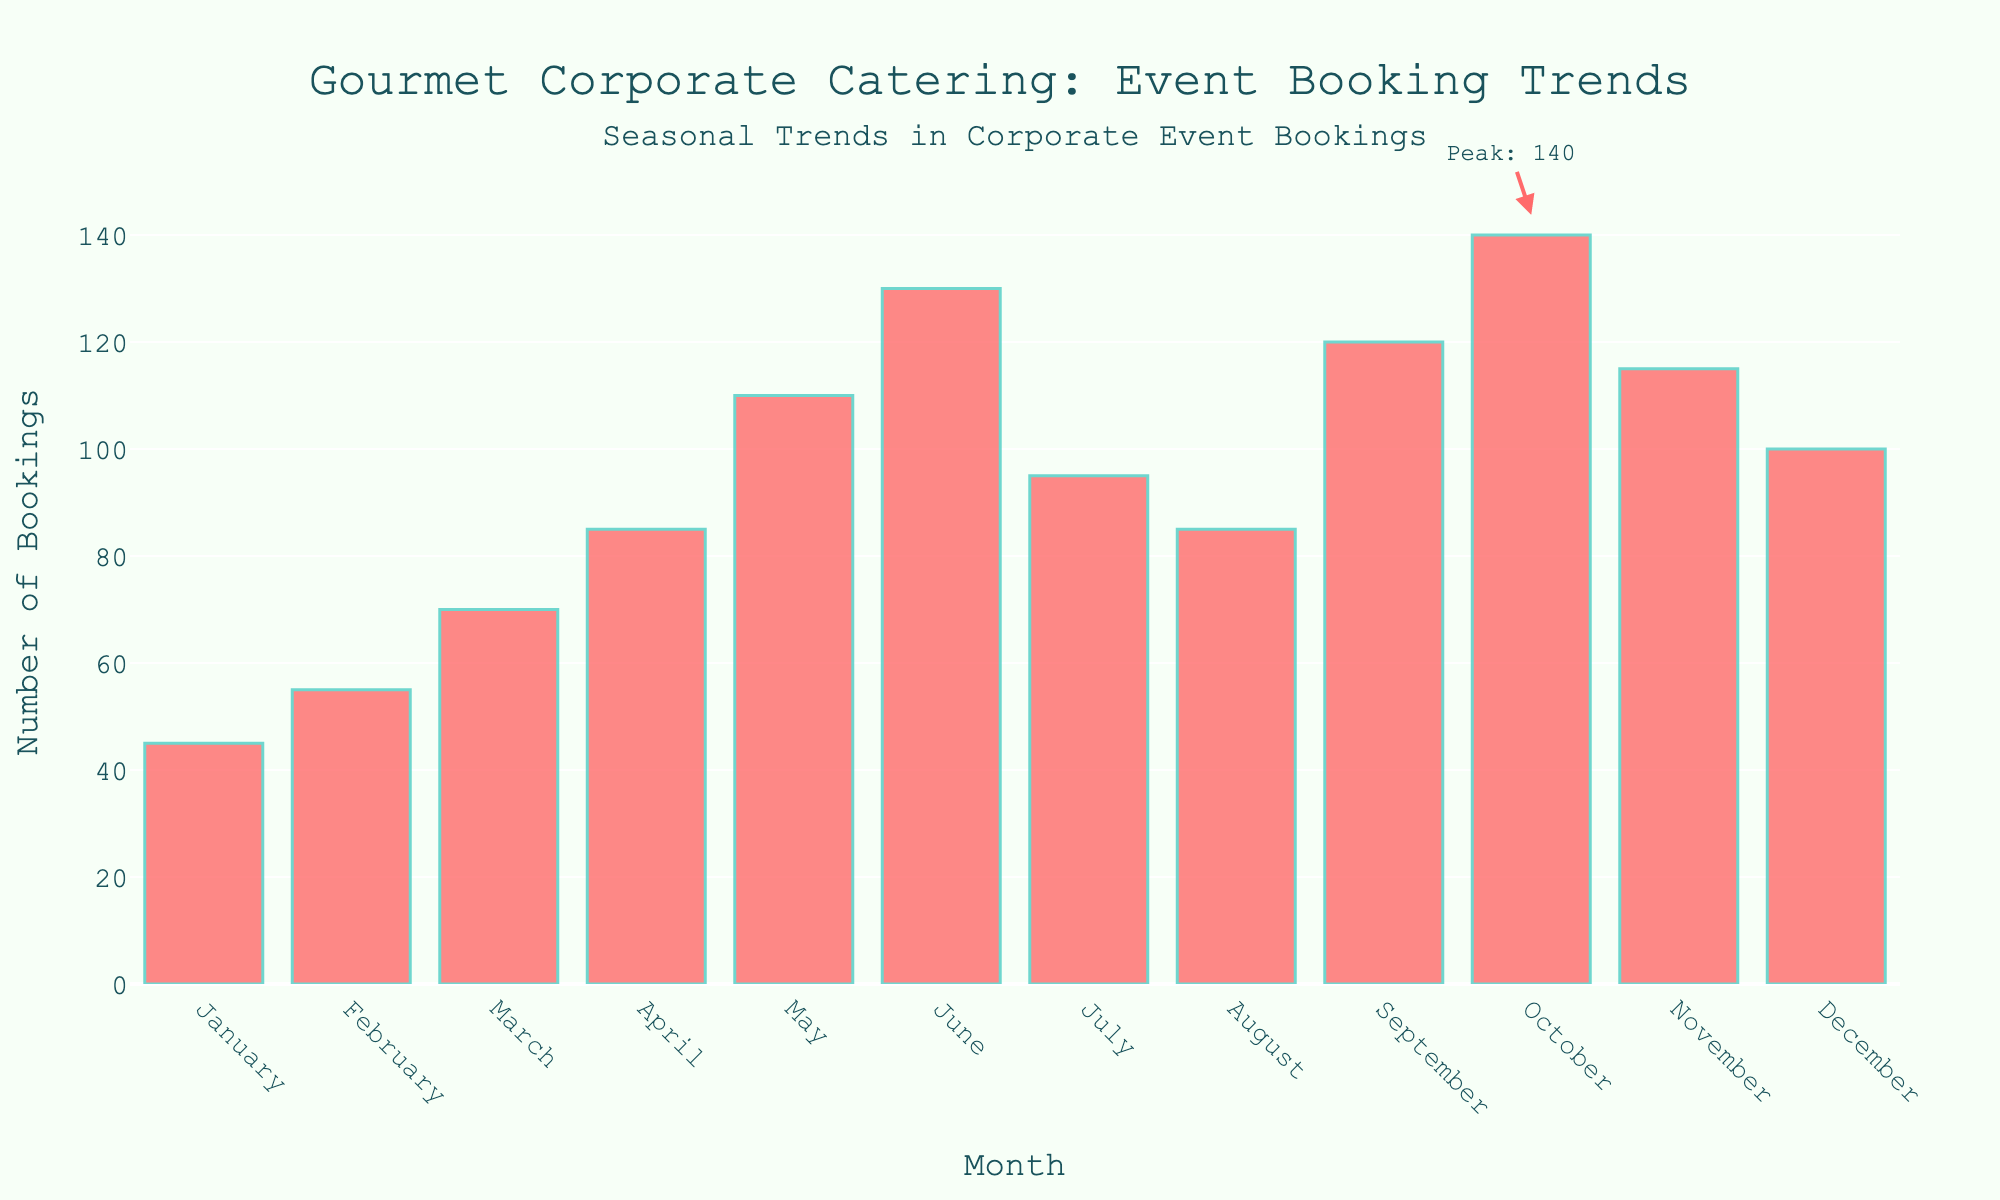What month sees the highest number of bookings? The month with the highest number of bookings can be identified by the tallest bar in the figure. October has the tallest bar.
Answer: October Compare the bookings of July and August. Which month has higher bookings? By looking at the height of the bars for July and August, July's bar is taller than August's.
Answer: July What is the difference in bookings between April and September? The bar for April is at 85 bookings, and the bar for September is at 120 bookings. The difference is 120 - 85 = 35 bookings.
Answer: 35 What is the range of the number of bookings throughout the year? The range can be found by subtracting the shortest bar's value (January with 45 bookings) from the tallest bar's value (October with 140 bookings). The range is 140 - 45 = 95 bookings.
Answer: 95 How many months have bookings above 100? The bars higher than the 100 bookings line are for May, June, September, October, and November. Counting these gives 5 months.
Answer: 5 What is the average number of bookings from January to June? Sum the bookings from January (45), February (55), March (70), April (85), May (110), and June (130). The sum is 495. The average is 495 / 6 = 82.5 bookings.
Answer: 82.5 Do more bookings occur in the first half or the second half of the year? Sum the bookings from January to June: 45 + 55 + 70 + 85 + 110 + 130 = 495. Sum the bookings from July to December: 95 + 85 + 120 + 140 + 115 + 100 = 655. Compare the sums: 655 > 495, so more bookings occur in the second half.
Answer: Second half Which month has the least number of bookings? The month with the least number of bookings can be identified by the shortest bar in the figure. January has the shortest bar.
Answer: January What is the sum of bookings in the last quarter of the year (October to December)? Sum the bookings from October (140), November (115), and December (100). The sum is 140 + 115 + 100 = 355 bookings.
Answer: 355 Compare the growth in bookings between March and April, and April and May. Which period has a higher increase? Compute the increase for March to April: 85 - 70 = 15 bookings. Compute the increase for April to May: 110 - 85 = 25 bookings. The April to May period shows a higher increase.
Answer: April to May 